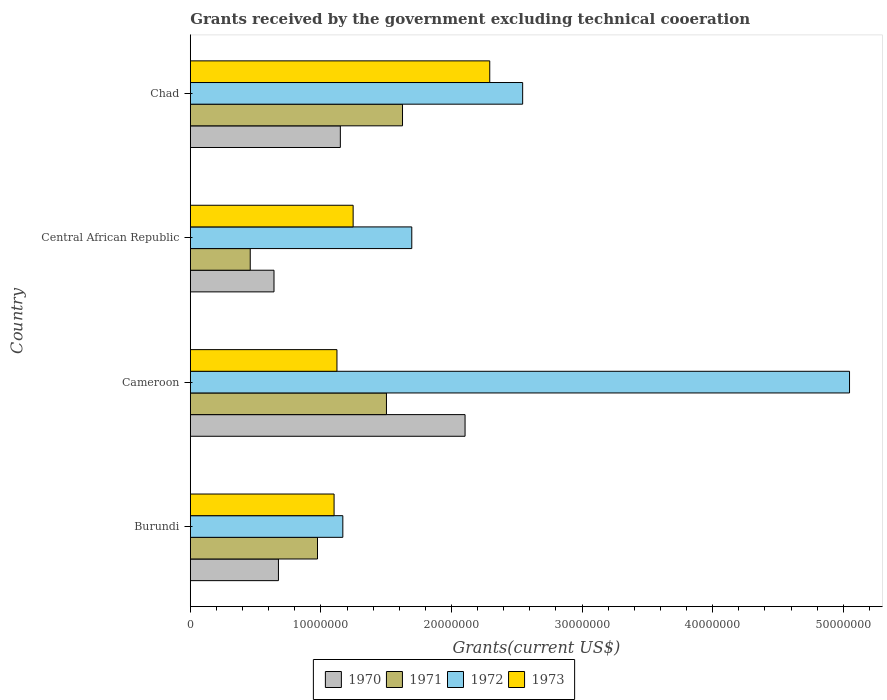How many different coloured bars are there?
Keep it short and to the point. 4. Are the number of bars on each tick of the Y-axis equal?
Make the answer very short. Yes. How many bars are there on the 4th tick from the top?
Your answer should be very brief. 4. How many bars are there on the 3rd tick from the bottom?
Your answer should be very brief. 4. What is the label of the 4th group of bars from the top?
Your response must be concise. Burundi. In how many cases, is the number of bars for a given country not equal to the number of legend labels?
Provide a short and direct response. 0. What is the total grants received by the government in 1973 in Chad?
Offer a very short reply. 2.29e+07. Across all countries, what is the maximum total grants received by the government in 1971?
Offer a terse response. 1.62e+07. Across all countries, what is the minimum total grants received by the government in 1970?
Your response must be concise. 6.41e+06. In which country was the total grants received by the government in 1972 maximum?
Your answer should be very brief. Cameroon. In which country was the total grants received by the government in 1973 minimum?
Your answer should be compact. Burundi. What is the total total grants received by the government in 1970 in the graph?
Give a very brief answer. 4.57e+07. What is the difference between the total grants received by the government in 1971 in Burundi and the total grants received by the government in 1972 in Cameroon?
Provide a succinct answer. -4.07e+07. What is the average total grants received by the government in 1973 per country?
Offer a very short reply. 1.44e+07. What is the difference between the total grants received by the government in 1971 and total grants received by the government in 1973 in Chad?
Offer a terse response. -6.68e+06. What is the ratio of the total grants received by the government in 1972 in Cameroon to that in Central African Republic?
Offer a terse response. 2.98. Is the total grants received by the government in 1973 in Cameroon less than that in Chad?
Your answer should be very brief. Yes. What is the difference between the highest and the second highest total grants received by the government in 1973?
Keep it short and to the point. 1.05e+07. What is the difference between the highest and the lowest total grants received by the government in 1972?
Provide a succinct answer. 3.88e+07. What does the 4th bar from the bottom in Central African Republic represents?
Your answer should be compact. 1973. Are all the bars in the graph horizontal?
Keep it short and to the point. Yes. How many countries are there in the graph?
Your response must be concise. 4. How are the legend labels stacked?
Keep it short and to the point. Horizontal. What is the title of the graph?
Ensure brevity in your answer.  Grants received by the government excluding technical cooeration. What is the label or title of the X-axis?
Keep it short and to the point. Grants(current US$). What is the label or title of the Y-axis?
Offer a very short reply. Country. What is the Grants(current US$) in 1970 in Burundi?
Give a very brief answer. 6.75e+06. What is the Grants(current US$) of 1971 in Burundi?
Your answer should be very brief. 9.74e+06. What is the Grants(current US$) of 1972 in Burundi?
Make the answer very short. 1.17e+07. What is the Grants(current US$) in 1973 in Burundi?
Offer a terse response. 1.10e+07. What is the Grants(current US$) of 1970 in Cameroon?
Offer a very short reply. 2.10e+07. What is the Grants(current US$) in 1971 in Cameroon?
Give a very brief answer. 1.50e+07. What is the Grants(current US$) of 1972 in Cameroon?
Offer a terse response. 5.05e+07. What is the Grants(current US$) in 1973 in Cameroon?
Your answer should be very brief. 1.12e+07. What is the Grants(current US$) of 1970 in Central African Republic?
Ensure brevity in your answer.  6.41e+06. What is the Grants(current US$) of 1971 in Central African Republic?
Your response must be concise. 4.59e+06. What is the Grants(current US$) of 1972 in Central African Republic?
Your answer should be compact. 1.70e+07. What is the Grants(current US$) in 1973 in Central African Republic?
Keep it short and to the point. 1.25e+07. What is the Grants(current US$) in 1970 in Chad?
Offer a terse response. 1.15e+07. What is the Grants(current US$) in 1971 in Chad?
Keep it short and to the point. 1.62e+07. What is the Grants(current US$) of 1972 in Chad?
Offer a very short reply. 2.54e+07. What is the Grants(current US$) in 1973 in Chad?
Keep it short and to the point. 2.29e+07. Across all countries, what is the maximum Grants(current US$) of 1970?
Your response must be concise. 2.10e+07. Across all countries, what is the maximum Grants(current US$) of 1971?
Your answer should be compact. 1.62e+07. Across all countries, what is the maximum Grants(current US$) of 1972?
Offer a very short reply. 5.05e+07. Across all countries, what is the maximum Grants(current US$) in 1973?
Your response must be concise. 2.29e+07. Across all countries, what is the minimum Grants(current US$) of 1970?
Give a very brief answer. 6.41e+06. Across all countries, what is the minimum Grants(current US$) in 1971?
Provide a succinct answer. 4.59e+06. Across all countries, what is the minimum Grants(current US$) in 1972?
Ensure brevity in your answer.  1.17e+07. Across all countries, what is the minimum Grants(current US$) of 1973?
Keep it short and to the point. 1.10e+07. What is the total Grants(current US$) of 1970 in the graph?
Keep it short and to the point. 4.57e+07. What is the total Grants(current US$) of 1971 in the graph?
Offer a very short reply. 4.56e+07. What is the total Grants(current US$) of 1972 in the graph?
Your response must be concise. 1.05e+08. What is the total Grants(current US$) in 1973 in the graph?
Offer a terse response. 5.76e+07. What is the difference between the Grants(current US$) in 1970 in Burundi and that in Cameroon?
Your answer should be compact. -1.43e+07. What is the difference between the Grants(current US$) in 1971 in Burundi and that in Cameroon?
Give a very brief answer. -5.28e+06. What is the difference between the Grants(current US$) in 1972 in Burundi and that in Cameroon?
Keep it short and to the point. -3.88e+07. What is the difference between the Grants(current US$) of 1973 in Burundi and that in Cameroon?
Give a very brief answer. -2.20e+05. What is the difference between the Grants(current US$) in 1971 in Burundi and that in Central African Republic?
Your answer should be very brief. 5.15e+06. What is the difference between the Grants(current US$) of 1972 in Burundi and that in Central African Republic?
Provide a short and direct response. -5.28e+06. What is the difference between the Grants(current US$) in 1973 in Burundi and that in Central African Republic?
Make the answer very short. -1.46e+06. What is the difference between the Grants(current US$) of 1970 in Burundi and that in Chad?
Ensure brevity in your answer.  -4.74e+06. What is the difference between the Grants(current US$) of 1971 in Burundi and that in Chad?
Provide a short and direct response. -6.51e+06. What is the difference between the Grants(current US$) of 1972 in Burundi and that in Chad?
Your answer should be compact. -1.38e+07. What is the difference between the Grants(current US$) in 1973 in Burundi and that in Chad?
Your response must be concise. -1.19e+07. What is the difference between the Grants(current US$) in 1970 in Cameroon and that in Central African Republic?
Offer a very short reply. 1.46e+07. What is the difference between the Grants(current US$) of 1971 in Cameroon and that in Central African Republic?
Provide a short and direct response. 1.04e+07. What is the difference between the Grants(current US$) in 1972 in Cameroon and that in Central African Republic?
Give a very brief answer. 3.35e+07. What is the difference between the Grants(current US$) of 1973 in Cameroon and that in Central African Republic?
Your answer should be compact. -1.24e+06. What is the difference between the Grants(current US$) of 1970 in Cameroon and that in Chad?
Keep it short and to the point. 9.55e+06. What is the difference between the Grants(current US$) of 1971 in Cameroon and that in Chad?
Your response must be concise. -1.23e+06. What is the difference between the Grants(current US$) in 1972 in Cameroon and that in Chad?
Your answer should be very brief. 2.50e+07. What is the difference between the Grants(current US$) in 1973 in Cameroon and that in Chad?
Make the answer very short. -1.17e+07. What is the difference between the Grants(current US$) of 1970 in Central African Republic and that in Chad?
Make the answer very short. -5.08e+06. What is the difference between the Grants(current US$) of 1971 in Central African Republic and that in Chad?
Provide a succinct answer. -1.17e+07. What is the difference between the Grants(current US$) in 1972 in Central African Republic and that in Chad?
Keep it short and to the point. -8.49e+06. What is the difference between the Grants(current US$) in 1973 in Central African Republic and that in Chad?
Your response must be concise. -1.05e+07. What is the difference between the Grants(current US$) of 1970 in Burundi and the Grants(current US$) of 1971 in Cameroon?
Offer a very short reply. -8.27e+06. What is the difference between the Grants(current US$) in 1970 in Burundi and the Grants(current US$) in 1972 in Cameroon?
Ensure brevity in your answer.  -4.37e+07. What is the difference between the Grants(current US$) in 1970 in Burundi and the Grants(current US$) in 1973 in Cameroon?
Offer a very short reply. -4.48e+06. What is the difference between the Grants(current US$) in 1971 in Burundi and the Grants(current US$) in 1972 in Cameroon?
Provide a succinct answer. -4.07e+07. What is the difference between the Grants(current US$) in 1971 in Burundi and the Grants(current US$) in 1973 in Cameroon?
Give a very brief answer. -1.49e+06. What is the difference between the Grants(current US$) of 1972 in Burundi and the Grants(current US$) of 1973 in Cameroon?
Give a very brief answer. 4.50e+05. What is the difference between the Grants(current US$) of 1970 in Burundi and the Grants(current US$) of 1971 in Central African Republic?
Provide a short and direct response. 2.16e+06. What is the difference between the Grants(current US$) in 1970 in Burundi and the Grants(current US$) in 1972 in Central African Republic?
Make the answer very short. -1.02e+07. What is the difference between the Grants(current US$) in 1970 in Burundi and the Grants(current US$) in 1973 in Central African Republic?
Your answer should be very brief. -5.72e+06. What is the difference between the Grants(current US$) of 1971 in Burundi and the Grants(current US$) of 1972 in Central African Republic?
Provide a succinct answer. -7.22e+06. What is the difference between the Grants(current US$) of 1971 in Burundi and the Grants(current US$) of 1973 in Central African Republic?
Offer a very short reply. -2.73e+06. What is the difference between the Grants(current US$) of 1972 in Burundi and the Grants(current US$) of 1973 in Central African Republic?
Provide a succinct answer. -7.90e+05. What is the difference between the Grants(current US$) of 1970 in Burundi and the Grants(current US$) of 1971 in Chad?
Provide a succinct answer. -9.50e+06. What is the difference between the Grants(current US$) in 1970 in Burundi and the Grants(current US$) in 1972 in Chad?
Keep it short and to the point. -1.87e+07. What is the difference between the Grants(current US$) in 1970 in Burundi and the Grants(current US$) in 1973 in Chad?
Your answer should be compact. -1.62e+07. What is the difference between the Grants(current US$) of 1971 in Burundi and the Grants(current US$) of 1972 in Chad?
Give a very brief answer. -1.57e+07. What is the difference between the Grants(current US$) of 1971 in Burundi and the Grants(current US$) of 1973 in Chad?
Keep it short and to the point. -1.32e+07. What is the difference between the Grants(current US$) of 1972 in Burundi and the Grants(current US$) of 1973 in Chad?
Your response must be concise. -1.12e+07. What is the difference between the Grants(current US$) in 1970 in Cameroon and the Grants(current US$) in 1971 in Central African Republic?
Your answer should be very brief. 1.64e+07. What is the difference between the Grants(current US$) in 1970 in Cameroon and the Grants(current US$) in 1972 in Central African Republic?
Provide a short and direct response. 4.08e+06. What is the difference between the Grants(current US$) in 1970 in Cameroon and the Grants(current US$) in 1973 in Central African Republic?
Provide a short and direct response. 8.57e+06. What is the difference between the Grants(current US$) in 1971 in Cameroon and the Grants(current US$) in 1972 in Central African Republic?
Your response must be concise. -1.94e+06. What is the difference between the Grants(current US$) of 1971 in Cameroon and the Grants(current US$) of 1973 in Central African Republic?
Ensure brevity in your answer.  2.55e+06. What is the difference between the Grants(current US$) in 1972 in Cameroon and the Grants(current US$) in 1973 in Central African Republic?
Offer a very short reply. 3.80e+07. What is the difference between the Grants(current US$) of 1970 in Cameroon and the Grants(current US$) of 1971 in Chad?
Provide a succinct answer. 4.79e+06. What is the difference between the Grants(current US$) of 1970 in Cameroon and the Grants(current US$) of 1972 in Chad?
Keep it short and to the point. -4.41e+06. What is the difference between the Grants(current US$) in 1970 in Cameroon and the Grants(current US$) in 1973 in Chad?
Provide a short and direct response. -1.89e+06. What is the difference between the Grants(current US$) in 1971 in Cameroon and the Grants(current US$) in 1972 in Chad?
Ensure brevity in your answer.  -1.04e+07. What is the difference between the Grants(current US$) of 1971 in Cameroon and the Grants(current US$) of 1973 in Chad?
Your response must be concise. -7.91e+06. What is the difference between the Grants(current US$) in 1972 in Cameroon and the Grants(current US$) in 1973 in Chad?
Offer a terse response. 2.76e+07. What is the difference between the Grants(current US$) of 1970 in Central African Republic and the Grants(current US$) of 1971 in Chad?
Your response must be concise. -9.84e+06. What is the difference between the Grants(current US$) in 1970 in Central African Republic and the Grants(current US$) in 1972 in Chad?
Your response must be concise. -1.90e+07. What is the difference between the Grants(current US$) in 1970 in Central African Republic and the Grants(current US$) in 1973 in Chad?
Your response must be concise. -1.65e+07. What is the difference between the Grants(current US$) in 1971 in Central African Republic and the Grants(current US$) in 1972 in Chad?
Keep it short and to the point. -2.09e+07. What is the difference between the Grants(current US$) in 1971 in Central African Republic and the Grants(current US$) in 1973 in Chad?
Offer a very short reply. -1.83e+07. What is the difference between the Grants(current US$) of 1972 in Central African Republic and the Grants(current US$) of 1973 in Chad?
Provide a succinct answer. -5.97e+06. What is the average Grants(current US$) in 1970 per country?
Make the answer very short. 1.14e+07. What is the average Grants(current US$) in 1971 per country?
Give a very brief answer. 1.14e+07. What is the average Grants(current US$) of 1972 per country?
Give a very brief answer. 2.61e+07. What is the average Grants(current US$) in 1973 per country?
Make the answer very short. 1.44e+07. What is the difference between the Grants(current US$) in 1970 and Grants(current US$) in 1971 in Burundi?
Ensure brevity in your answer.  -2.99e+06. What is the difference between the Grants(current US$) of 1970 and Grants(current US$) of 1972 in Burundi?
Give a very brief answer. -4.93e+06. What is the difference between the Grants(current US$) of 1970 and Grants(current US$) of 1973 in Burundi?
Your answer should be compact. -4.26e+06. What is the difference between the Grants(current US$) in 1971 and Grants(current US$) in 1972 in Burundi?
Your answer should be very brief. -1.94e+06. What is the difference between the Grants(current US$) in 1971 and Grants(current US$) in 1973 in Burundi?
Give a very brief answer. -1.27e+06. What is the difference between the Grants(current US$) of 1972 and Grants(current US$) of 1973 in Burundi?
Provide a succinct answer. 6.70e+05. What is the difference between the Grants(current US$) in 1970 and Grants(current US$) in 1971 in Cameroon?
Your response must be concise. 6.02e+06. What is the difference between the Grants(current US$) of 1970 and Grants(current US$) of 1972 in Cameroon?
Ensure brevity in your answer.  -2.94e+07. What is the difference between the Grants(current US$) of 1970 and Grants(current US$) of 1973 in Cameroon?
Make the answer very short. 9.81e+06. What is the difference between the Grants(current US$) in 1971 and Grants(current US$) in 1972 in Cameroon?
Provide a succinct answer. -3.55e+07. What is the difference between the Grants(current US$) in 1971 and Grants(current US$) in 1973 in Cameroon?
Provide a short and direct response. 3.79e+06. What is the difference between the Grants(current US$) in 1972 and Grants(current US$) in 1973 in Cameroon?
Provide a succinct answer. 3.92e+07. What is the difference between the Grants(current US$) in 1970 and Grants(current US$) in 1971 in Central African Republic?
Make the answer very short. 1.82e+06. What is the difference between the Grants(current US$) in 1970 and Grants(current US$) in 1972 in Central African Republic?
Your response must be concise. -1.06e+07. What is the difference between the Grants(current US$) in 1970 and Grants(current US$) in 1973 in Central African Republic?
Keep it short and to the point. -6.06e+06. What is the difference between the Grants(current US$) in 1971 and Grants(current US$) in 1972 in Central African Republic?
Provide a short and direct response. -1.24e+07. What is the difference between the Grants(current US$) in 1971 and Grants(current US$) in 1973 in Central African Republic?
Give a very brief answer. -7.88e+06. What is the difference between the Grants(current US$) in 1972 and Grants(current US$) in 1973 in Central African Republic?
Provide a short and direct response. 4.49e+06. What is the difference between the Grants(current US$) of 1970 and Grants(current US$) of 1971 in Chad?
Provide a short and direct response. -4.76e+06. What is the difference between the Grants(current US$) in 1970 and Grants(current US$) in 1972 in Chad?
Provide a short and direct response. -1.40e+07. What is the difference between the Grants(current US$) of 1970 and Grants(current US$) of 1973 in Chad?
Give a very brief answer. -1.14e+07. What is the difference between the Grants(current US$) of 1971 and Grants(current US$) of 1972 in Chad?
Offer a very short reply. -9.20e+06. What is the difference between the Grants(current US$) in 1971 and Grants(current US$) in 1973 in Chad?
Offer a very short reply. -6.68e+06. What is the difference between the Grants(current US$) in 1972 and Grants(current US$) in 1973 in Chad?
Your answer should be very brief. 2.52e+06. What is the ratio of the Grants(current US$) in 1970 in Burundi to that in Cameroon?
Your response must be concise. 0.32. What is the ratio of the Grants(current US$) in 1971 in Burundi to that in Cameroon?
Your response must be concise. 0.65. What is the ratio of the Grants(current US$) in 1972 in Burundi to that in Cameroon?
Keep it short and to the point. 0.23. What is the ratio of the Grants(current US$) in 1973 in Burundi to that in Cameroon?
Offer a terse response. 0.98. What is the ratio of the Grants(current US$) of 1970 in Burundi to that in Central African Republic?
Ensure brevity in your answer.  1.05. What is the ratio of the Grants(current US$) in 1971 in Burundi to that in Central African Republic?
Your response must be concise. 2.12. What is the ratio of the Grants(current US$) in 1972 in Burundi to that in Central African Republic?
Offer a terse response. 0.69. What is the ratio of the Grants(current US$) in 1973 in Burundi to that in Central African Republic?
Make the answer very short. 0.88. What is the ratio of the Grants(current US$) in 1970 in Burundi to that in Chad?
Ensure brevity in your answer.  0.59. What is the ratio of the Grants(current US$) in 1971 in Burundi to that in Chad?
Provide a succinct answer. 0.6. What is the ratio of the Grants(current US$) in 1972 in Burundi to that in Chad?
Make the answer very short. 0.46. What is the ratio of the Grants(current US$) in 1973 in Burundi to that in Chad?
Give a very brief answer. 0.48. What is the ratio of the Grants(current US$) in 1970 in Cameroon to that in Central African Republic?
Ensure brevity in your answer.  3.28. What is the ratio of the Grants(current US$) of 1971 in Cameroon to that in Central African Republic?
Provide a succinct answer. 3.27. What is the ratio of the Grants(current US$) in 1972 in Cameroon to that in Central African Republic?
Offer a terse response. 2.98. What is the ratio of the Grants(current US$) in 1973 in Cameroon to that in Central African Republic?
Make the answer very short. 0.9. What is the ratio of the Grants(current US$) of 1970 in Cameroon to that in Chad?
Provide a succinct answer. 1.83. What is the ratio of the Grants(current US$) in 1971 in Cameroon to that in Chad?
Offer a very short reply. 0.92. What is the ratio of the Grants(current US$) of 1972 in Cameroon to that in Chad?
Offer a terse response. 1.98. What is the ratio of the Grants(current US$) of 1973 in Cameroon to that in Chad?
Your answer should be compact. 0.49. What is the ratio of the Grants(current US$) in 1970 in Central African Republic to that in Chad?
Ensure brevity in your answer.  0.56. What is the ratio of the Grants(current US$) of 1971 in Central African Republic to that in Chad?
Give a very brief answer. 0.28. What is the ratio of the Grants(current US$) in 1972 in Central African Republic to that in Chad?
Your answer should be compact. 0.67. What is the ratio of the Grants(current US$) in 1973 in Central African Republic to that in Chad?
Provide a short and direct response. 0.54. What is the difference between the highest and the second highest Grants(current US$) in 1970?
Provide a short and direct response. 9.55e+06. What is the difference between the highest and the second highest Grants(current US$) of 1971?
Ensure brevity in your answer.  1.23e+06. What is the difference between the highest and the second highest Grants(current US$) in 1972?
Make the answer very short. 2.50e+07. What is the difference between the highest and the second highest Grants(current US$) in 1973?
Offer a very short reply. 1.05e+07. What is the difference between the highest and the lowest Grants(current US$) in 1970?
Keep it short and to the point. 1.46e+07. What is the difference between the highest and the lowest Grants(current US$) in 1971?
Offer a very short reply. 1.17e+07. What is the difference between the highest and the lowest Grants(current US$) of 1972?
Offer a terse response. 3.88e+07. What is the difference between the highest and the lowest Grants(current US$) in 1973?
Your response must be concise. 1.19e+07. 